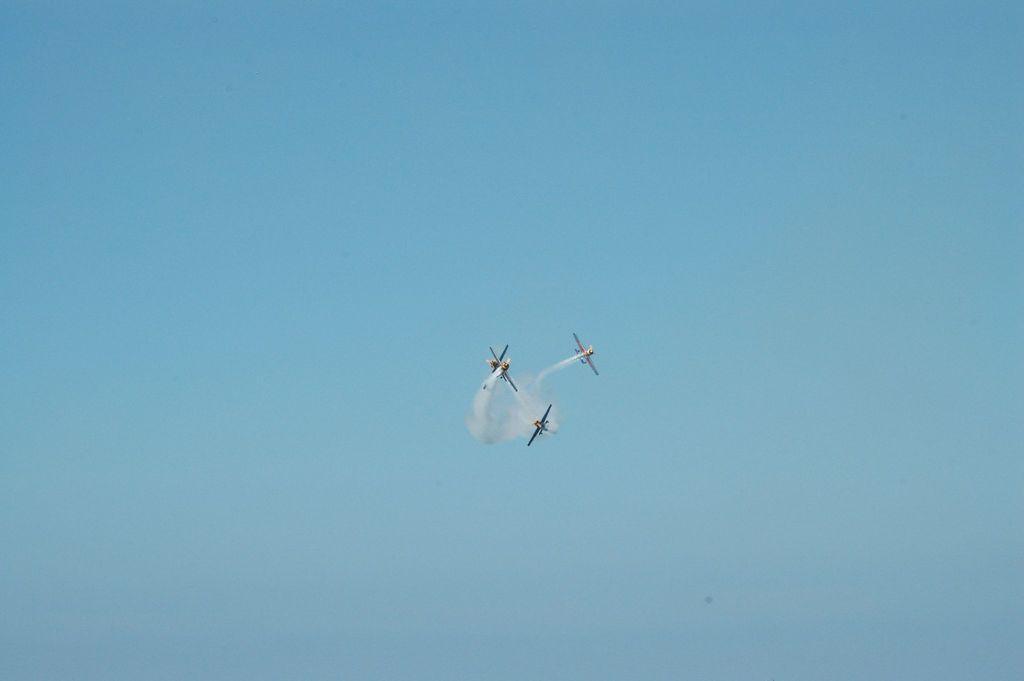Can you describe this image briefly? In this image we can see aeroplanes flying in the sky. 